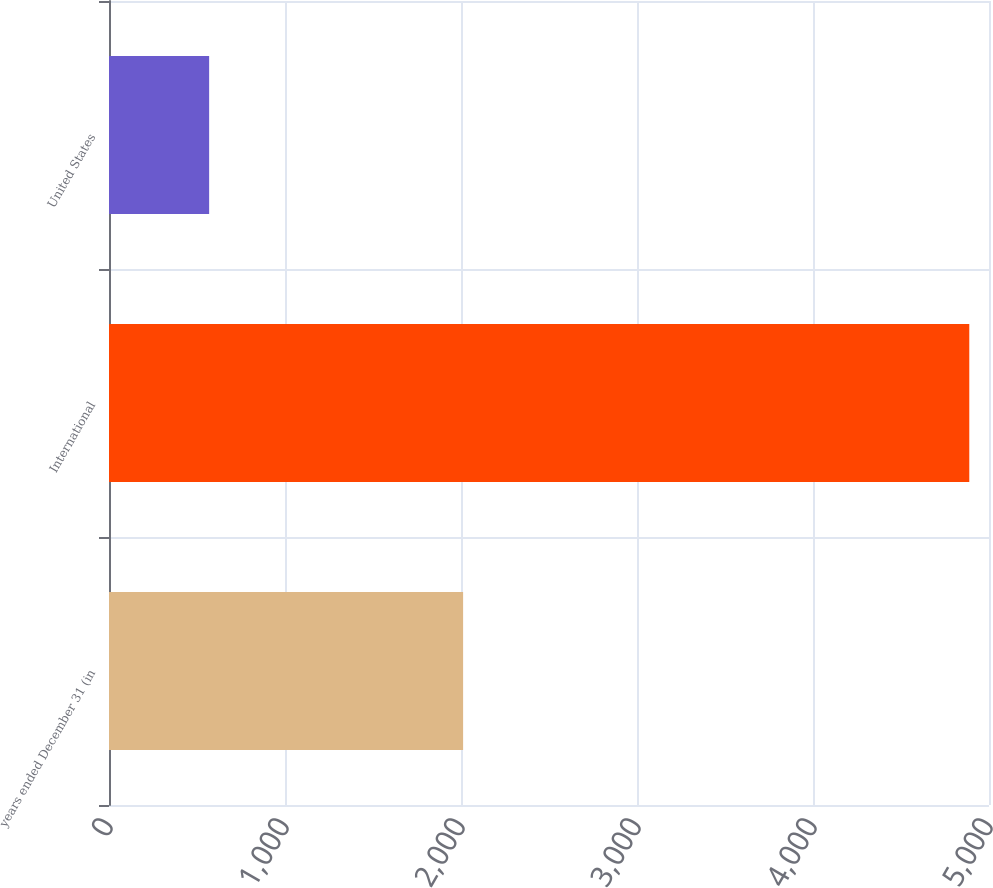Convert chart to OTSL. <chart><loc_0><loc_0><loc_500><loc_500><bar_chart><fcel>years ended December 31 (in<fcel>International<fcel>United States<nl><fcel>2012<fcel>4888<fcel>569<nl></chart> 